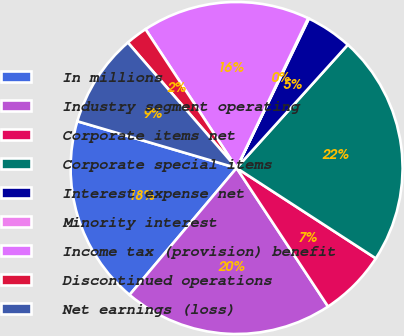<chart> <loc_0><loc_0><loc_500><loc_500><pie_chart><fcel>In millions<fcel>Industry segment operating<fcel>Corporate items net<fcel>Corporate special items<fcel>Interest expense net<fcel>Minority interest<fcel>Income tax (provision) benefit<fcel>Discontinued operations<fcel>Net earnings (loss)<nl><fcel>18.39%<fcel>20.44%<fcel>6.55%<fcel>22.48%<fcel>4.51%<fcel>0.08%<fcel>16.34%<fcel>2.12%<fcel>9.09%<nl></chart> 